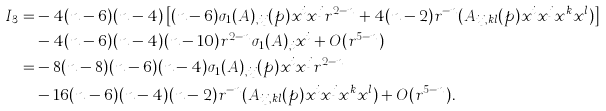<formula> <loc_0><loc_0><loc_500><loc_500>I _ { 3 } = & - 4 ( n - 6 ) ( n - 4 ) \left [ ( n - 6 ) \sigma _ { 1 } ( A ) _ { , i j } ( p ) x ^ { i } x ^ { j } r ^ { 2 - n } + 4 ( n - 2 ) r ^ { - n } ( A _ { i j , k l } ( p ) x ^ { i } x ^ { j } x ^ { k } x ^ { l } ) \right ] \\ & - 4 ( n - 6 ) ( n - 4 ) ( n - 1 0 ) r ^ { 2 - n } \sigma _ { 1 } ( A ) _ { , i } x ^ { i } + O ( r ^ { 5 - n } ) \\ = & - 8 ( n - 8 ) ( n - 6 ) ( n - 4 ) \sigma _ { 1 } ( A ) _ { , i j } ( p ) x ^ { i } x ^ { j } r ^ { 2 - n } \\ & - 1 6 ( n - 6 ) ( n - 4 ) ( n - 2 ) r ^ { - n } ( A _ { i j , k l } ( p ) x ^ { i } x ^ { j } x ^ { k } x ^ { l } ) + O ( r ^ { 5 - n } ) .</formula> 